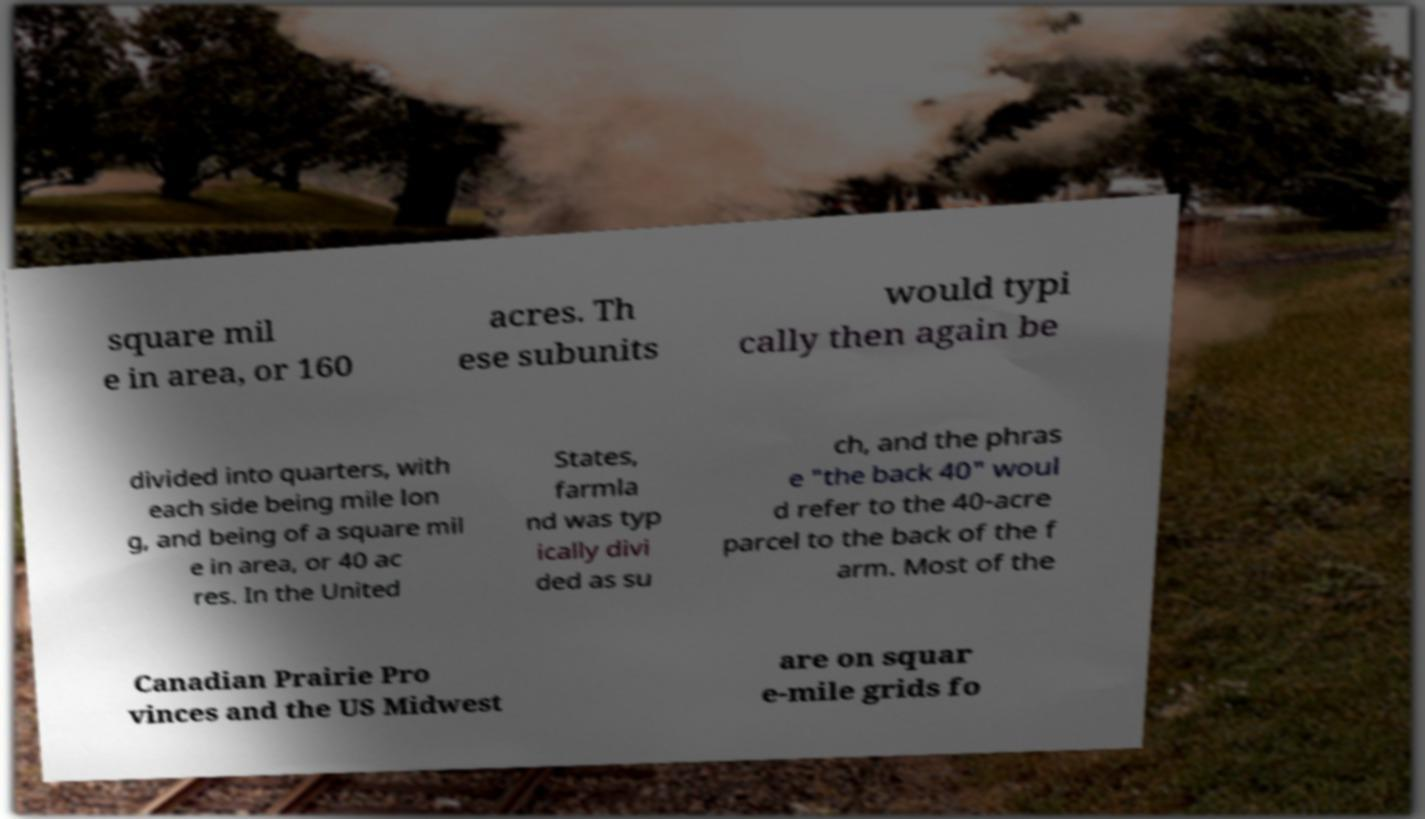I need the written content from this picture converted into text. Can you do that? square mil e in area, or 160 acres. Th ese subunits would typi cally then again be divided into quarters, with each side being mile lon g, and being of a square mil e in area, or 40 ac res. In the United States, farmla nd was typ ically divi ded as su ch, and the phras e "the back 40" woul d refer to the 40-acre parcel to the back of the f arm. Most of the Canadian Prairie Pro vinces and the US Midwest are on squar e-mile grids fo 